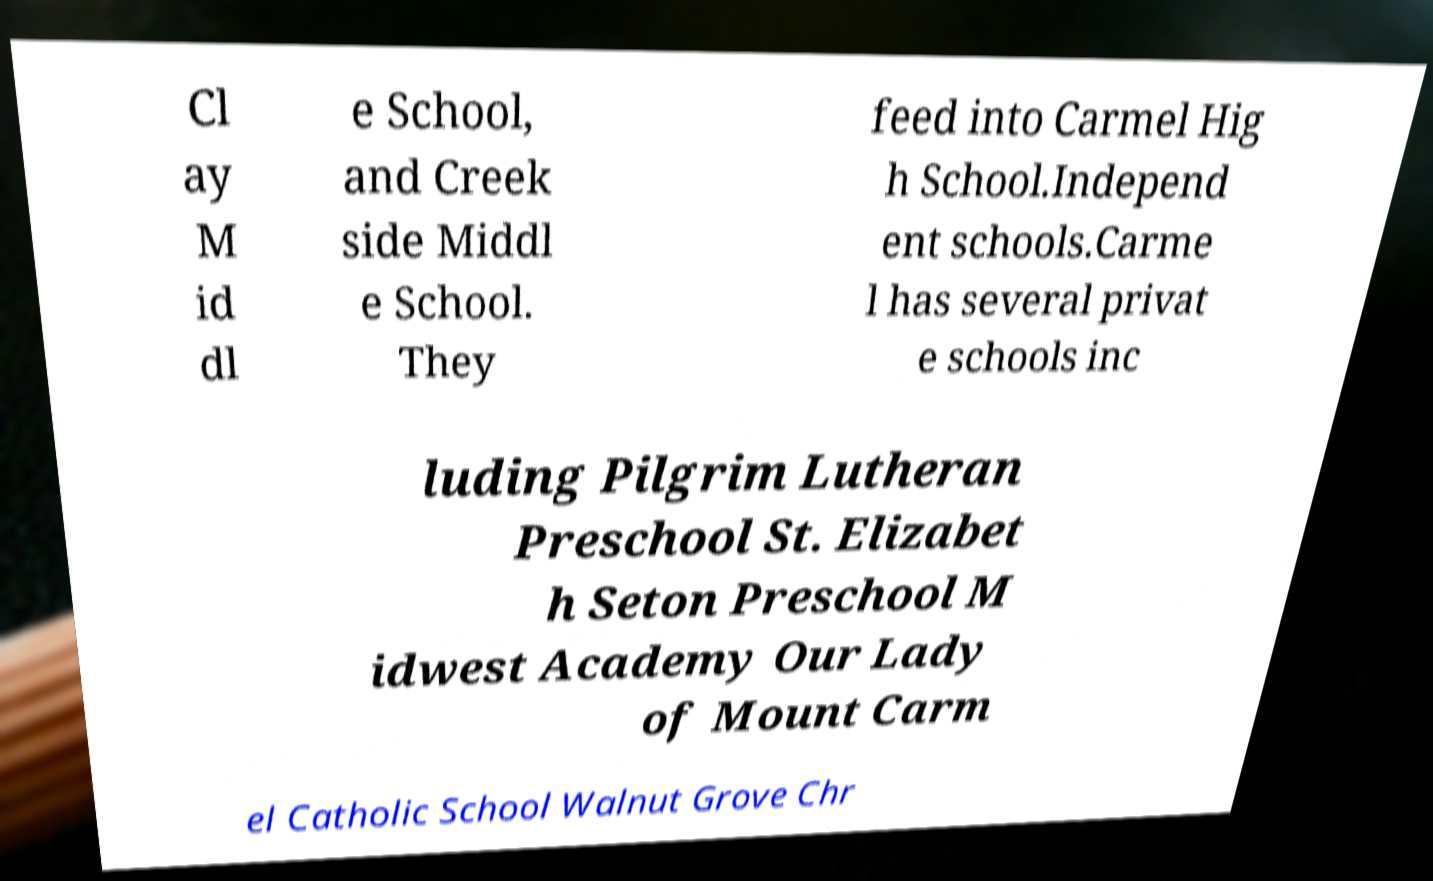I need the written content from this picture converted into text. Can you do that? Cl ay M id dl e School, and Creek side Middl e School. They feed into Carmel Hig h School.Independ ent schools.Carme l has several privat e schools inc luding Pilgrim Lutheran Preschool St. Elizabet h Seton Preschool M idwest Academy Our Lady of Mount Carm el Catholic School Walnut Grove Chr 